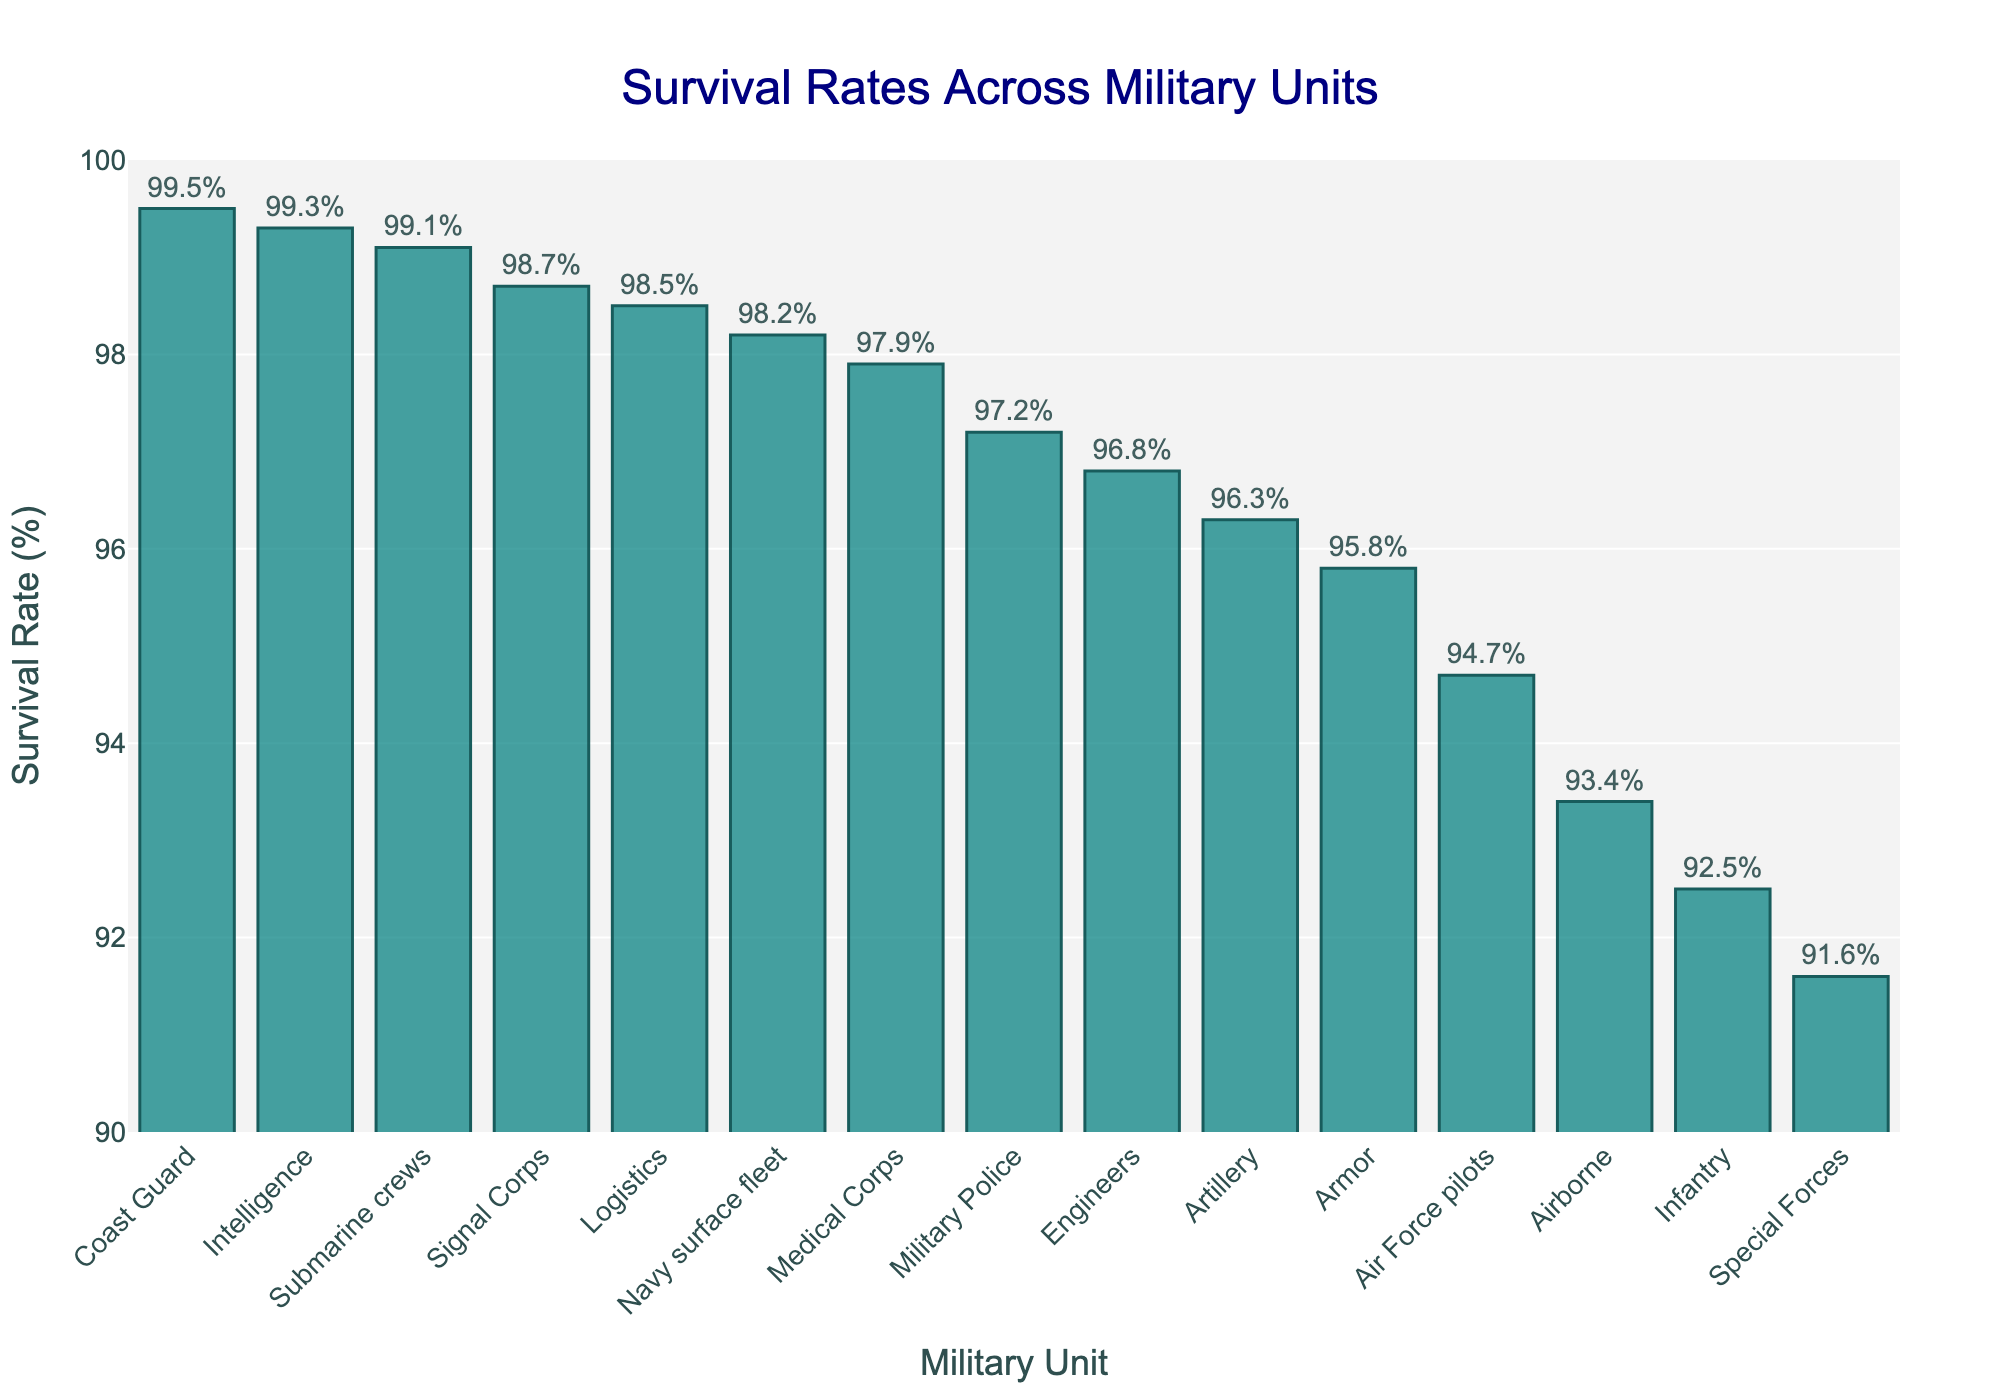Which military unit has the highest survival rate? The unit with the highest bar represents the highest survival rate. In the figure, this is the Coast Guard.
Answer: Coast Guard Which military units have survival rates above 95.0%? Look for bars that extend above the 95.0% mark on the y-axis. The units above 95.0% are Armor, Artillery, Air Force pilots, Navy surface fleet, Submarine crews, Medical Corps, Logistics, Military Police, Engineers, Signal Corps, Intelligence, and Coast Guard.
Answer: Armor, Artillery, Air Force pilots, Navy surface fleet, Submarine crews, Medical Corps, Logistics, Military Police, Engineers, Signal Corps, Intelligence, Coast Guard Compare the survival rates of Infantry and Special Forces; which has a higher rate? Examine the heights of the bars for Infantry and Special Forces and compare them. Infantry has a survival rate of 92.5% and Special Forces have 91.6%. Therefore, Infantry has a higher rate.
Answer: Infantry What is the average survival rate of the Coast Guard, Intelligence, and Submarine crews? Add the survival rates of Coast Guard, Intelligence, and Submarine crews then divide by 3: (99.5 + 99.3 + 99.1)/3 = 99.3%
Answer: 99.3% How does the survival rate of Medical Corps compare to that of Engineers? Compare the heights of the bars for Medical Corps (97.9%) and Engineers (96.8%). Medical Corps has a higher rate.
Answer: Medical Corps What is the difference in survival rates between the Airborne and Infantry units? Subtract the survival rate of Infantry (92.5%) from that of Airborne (93.4%) to find the difference: 93.4% - 92.5% = 0.9%
Answer: 0.9% Identify all the units with survival rates between 96.0% and 98.0%. Find the bars whose heights are between 96.0% and 98.0%. They are Artillery, Engineers, Medical Corps, and Military Police.
Answer: Artillery, Engineers, Medical Corps, Military Police What is the median survival rate of all the units? Arrange the units’ survival rates and find the middle value. Ordered rates: 91.6%, 92.5%, 93.4%, 94.7%, 95.8%, 96.3%, 96.8%, 97.2%, 97.9%, 98.2%, 98.5%, 98.7%, 99.1%, 99.3%, 99.5%. The middle value (8th) is 97.2%.
Answer: 97.2% Which unit has a survival rate closest to 95.0%? Identify the bar whose height is nearest to 95.0%. The closest unit is Armor at 95.8%.
Answer: Armor 